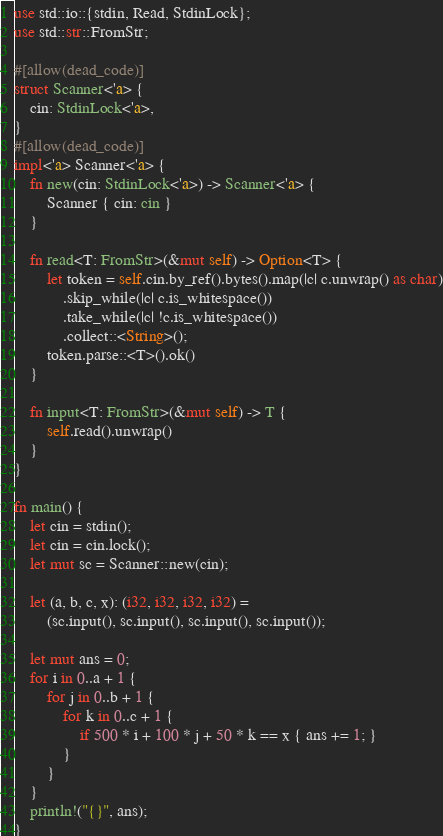Convert code to text. <code><loc_0><loc_0><loc_500><loc_500><_Rust_>use std::io::{stdin, Read, StdinLock};
use std::str::FromStr;

#[allow(dead_code)]
struct Scanner<'a> {
    cin: StdinLock<'a>,
}
#[allow(dead_code)]
impl<'a> Scanner<'a> {
    fn new(cin: StdinLock<'a>) -> Scanner<'a> {
        Scanner { cin: cin }
    }

    fn read<T: FromStr>(&mut self) -> Option<T> {
        let token = self.cin.by_ref().bytes().map(|c| c.unwrap() as char)
            .skip_while(|c| c.is_whitespace())
            .take_while(|c| !c.is_whitespace())
            .collect::<String>();
        token.parse::<T>().ok()
    }

    fn input<T: FromStr>(&mut self) -> T {
        self.read().unwrap()
    }
}

fn main() {
    let cin = stdin();
    let cin = cin.lock();
    let mut sc = Scanner::new(cin);

    let (a, b, c, x): (i32, i32, i32, i32) =
        (sc.input(), sc.input(), sc.input(), sc.input());

    let mut ans = 0;
    for i in 0..a + 1 {
        for j in 0..b + 1 {
            for k in 0..c + 1 {
                if 500 * i + 100 * j + 50 * k == x { ans += 1; }
            }
        }
    }
    println!("{}", ans);
}
</code> 